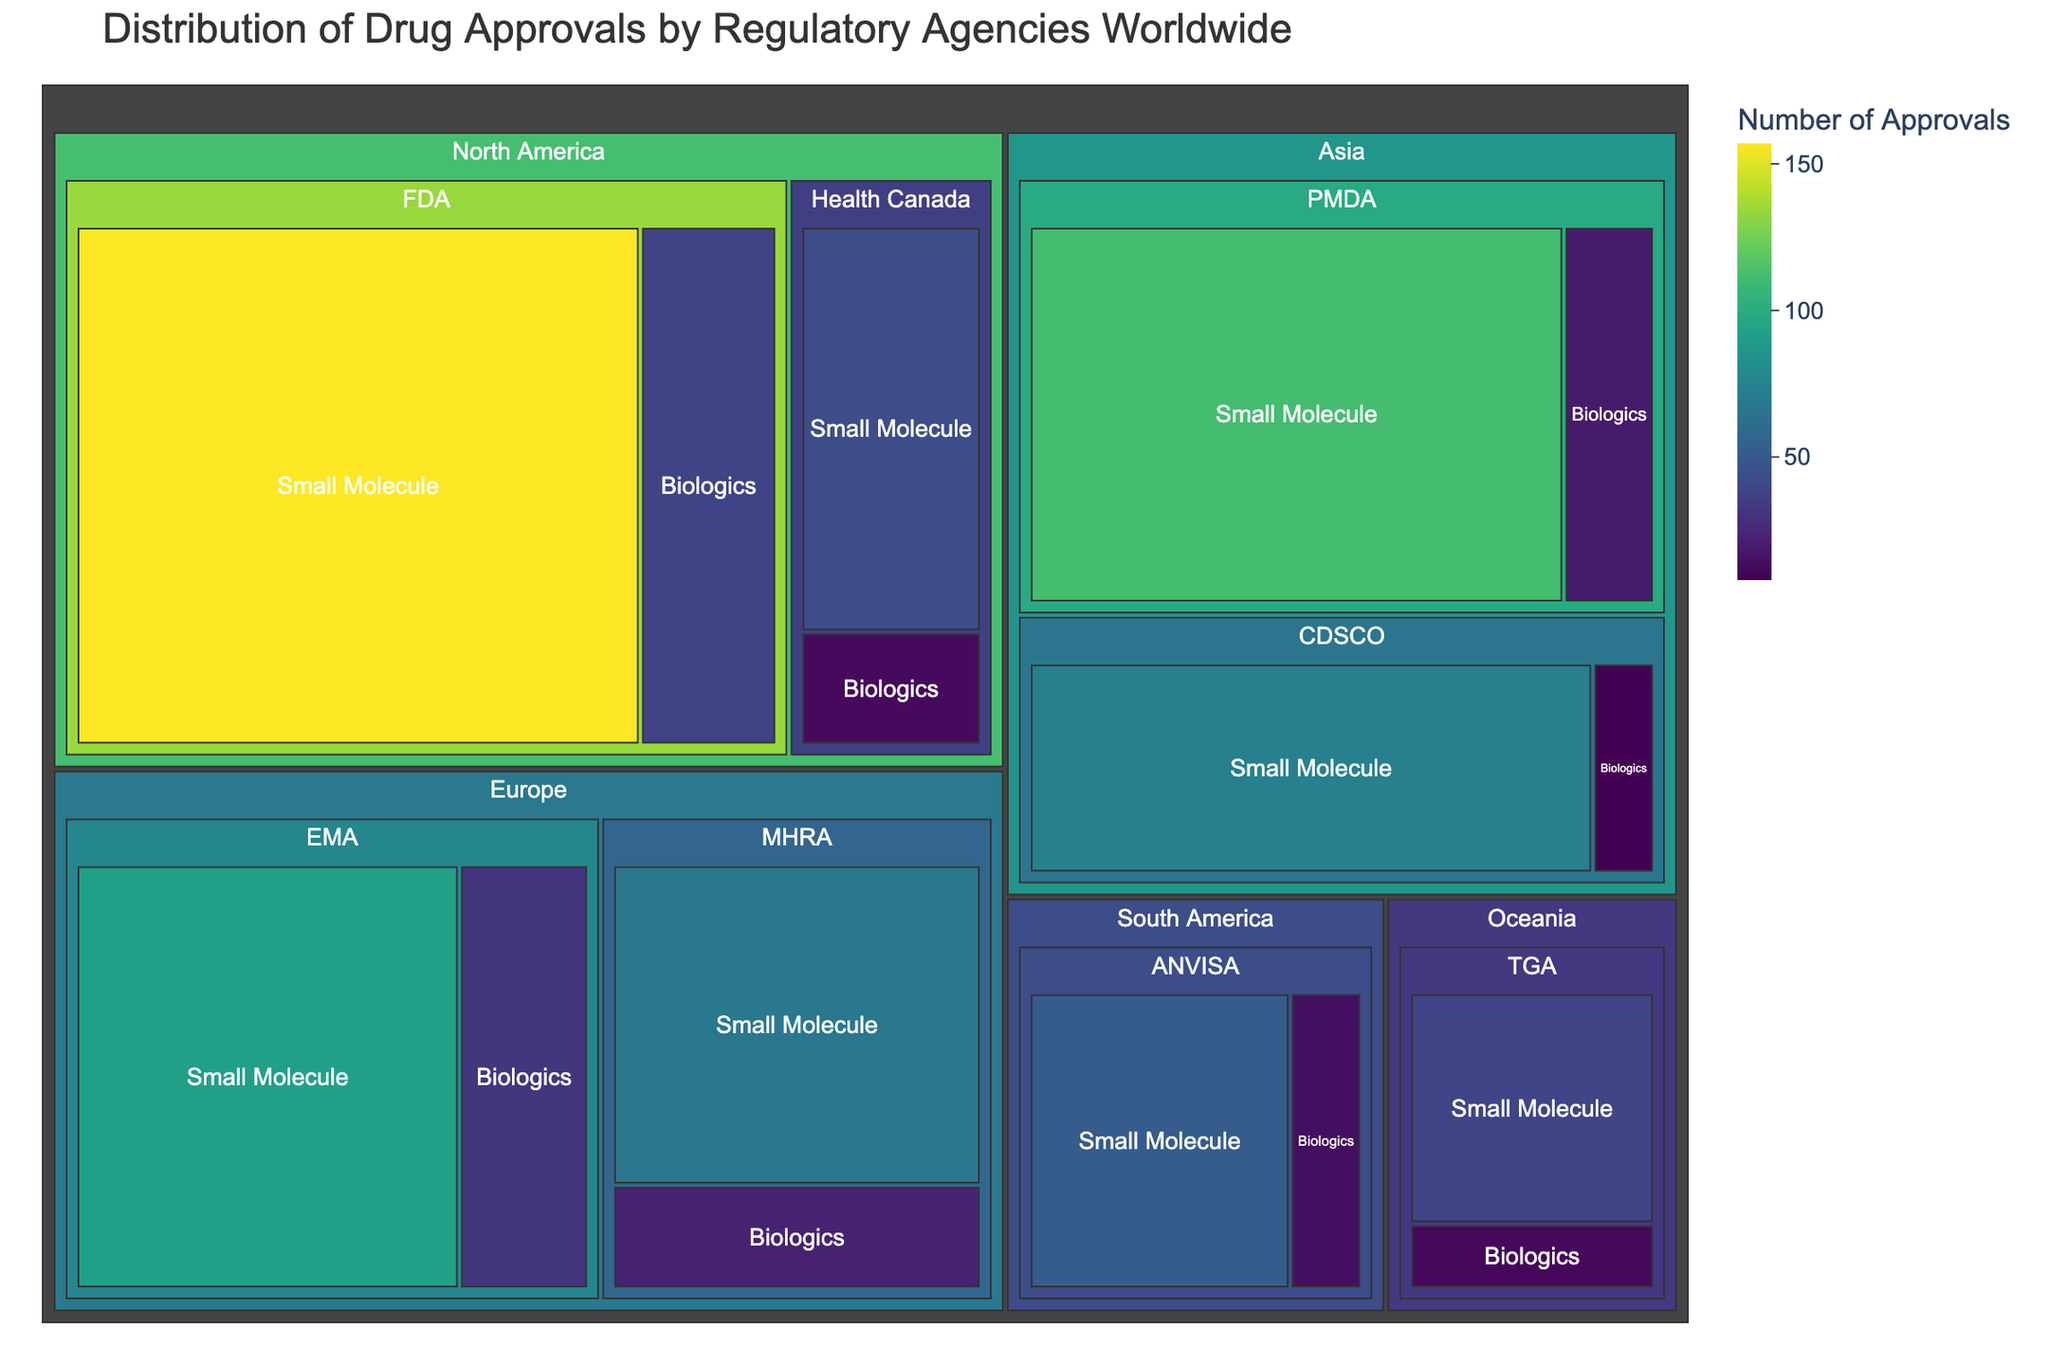How many drug approvals does the FDA have for small molecules? On the treemap, locate the region "North America" and then the regulatory agency "FDA." Check the number of drug approvals for "Small Molecule."
Answer: 157 What's the total number of drug approvals in Europe? Sum the approvals for both the EMA and MHRA for small molecules and biologics. EMA: 92 (Small Molecule) + 31 (Biologics), MHRA: 68 (Small Molecule) + 22 (Biologics). Total: 92 + 31 + 68 + 22 = 213
Answer: 213 Which regulatory agency has the highest number of biologics approvals? Check the values for all regulatory agencies under the "Biologics" category. Compare them: FDA (38), EMA (31), PMDA (19), Health Canada (12), MHRA (22), TGA (11), ANVISA (14), CDSCO (8). The FDA has the highest with 38.
Answer: FDA What is the difference in the number of small molecule approvals between PMDA and CDSCO? Locate "Small Molecule" approvals for PMDA (112) and CDSCO (73). Subtract the two values: 112 - 73 = 39
Answer: 39 Which region has the most diverse types of drug approvals? Count the number of drug types (small molecule and biologics) under each region and compare. Each region contains both drug types, but North America (FDA + Health Canada) has a higher number of individual approvals than any other region.
Answer: North America What percentage of FDA's drug approvals are biologics? Calculate the ratio of biologics to the total FDA approvals. FDA Biologics: 38, FDA total: 157 (Small Molecule) + 38 (Biologics) = 195. Ratio: (38/195) * 100 ≈ 19.49%
Answer: ≈ 19.49% Among the presented regions, which has the fewest total drug approvals, and what is the number? Compare total drug approvals for all regions. Sum of approvals for each region, Oceania (TGA) has the fewest: 39 (Small Molecule) + 11 (Biologics) = 50
Answer: Oceania, 50 What is the combined total of biologic approvals by European agencies (EMA and MHRA)? Add the biologic approvals for EMA (31) and MHRA (22). Total: 31 + 22 = 53
Answer: 53 